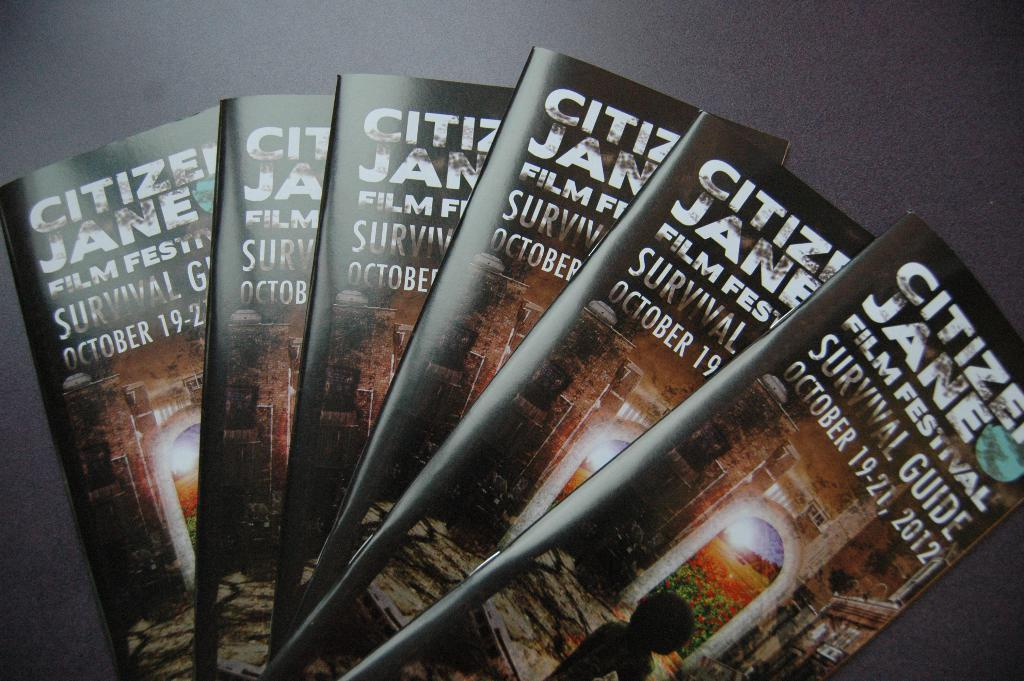<image>
Relay a brief, clear account of the picture shown. Several copies of the Citizen Jane film festival pamphlet are fanned out together. 